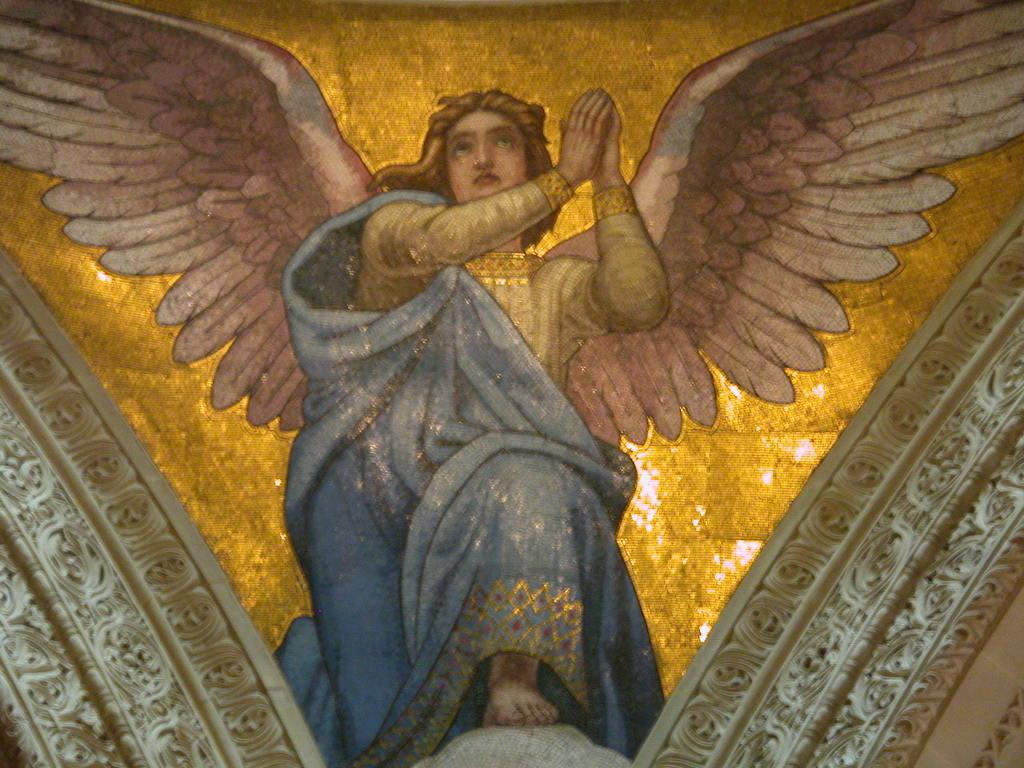What is the main subject of the image? There is a painting in the image. What is the person in the painting wearing? The person in the painting is wearing a blue dress. What distinguishing feature does the person in the painting have? The person in the painting has wings. What is the color of the background in the painting? The background of the painting is gold in color. What is the weight of the cart in the image? There is no cart present in the image. How does the person in the painting carry the weight of their wings? The image is a painting and does not depict the person carrying any actual weight. 